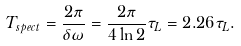Convert formula to latex. <formula><loc_0><loc_0><loc_500><loc_500>T _ { s p e c t } = \frac { 2 \pi } { \delta \omega } = \frac { 2 \pi } { 4 \ln 2 } \tau _ { L } = 2 . 2 6 \tau _ { L } .</formula> 